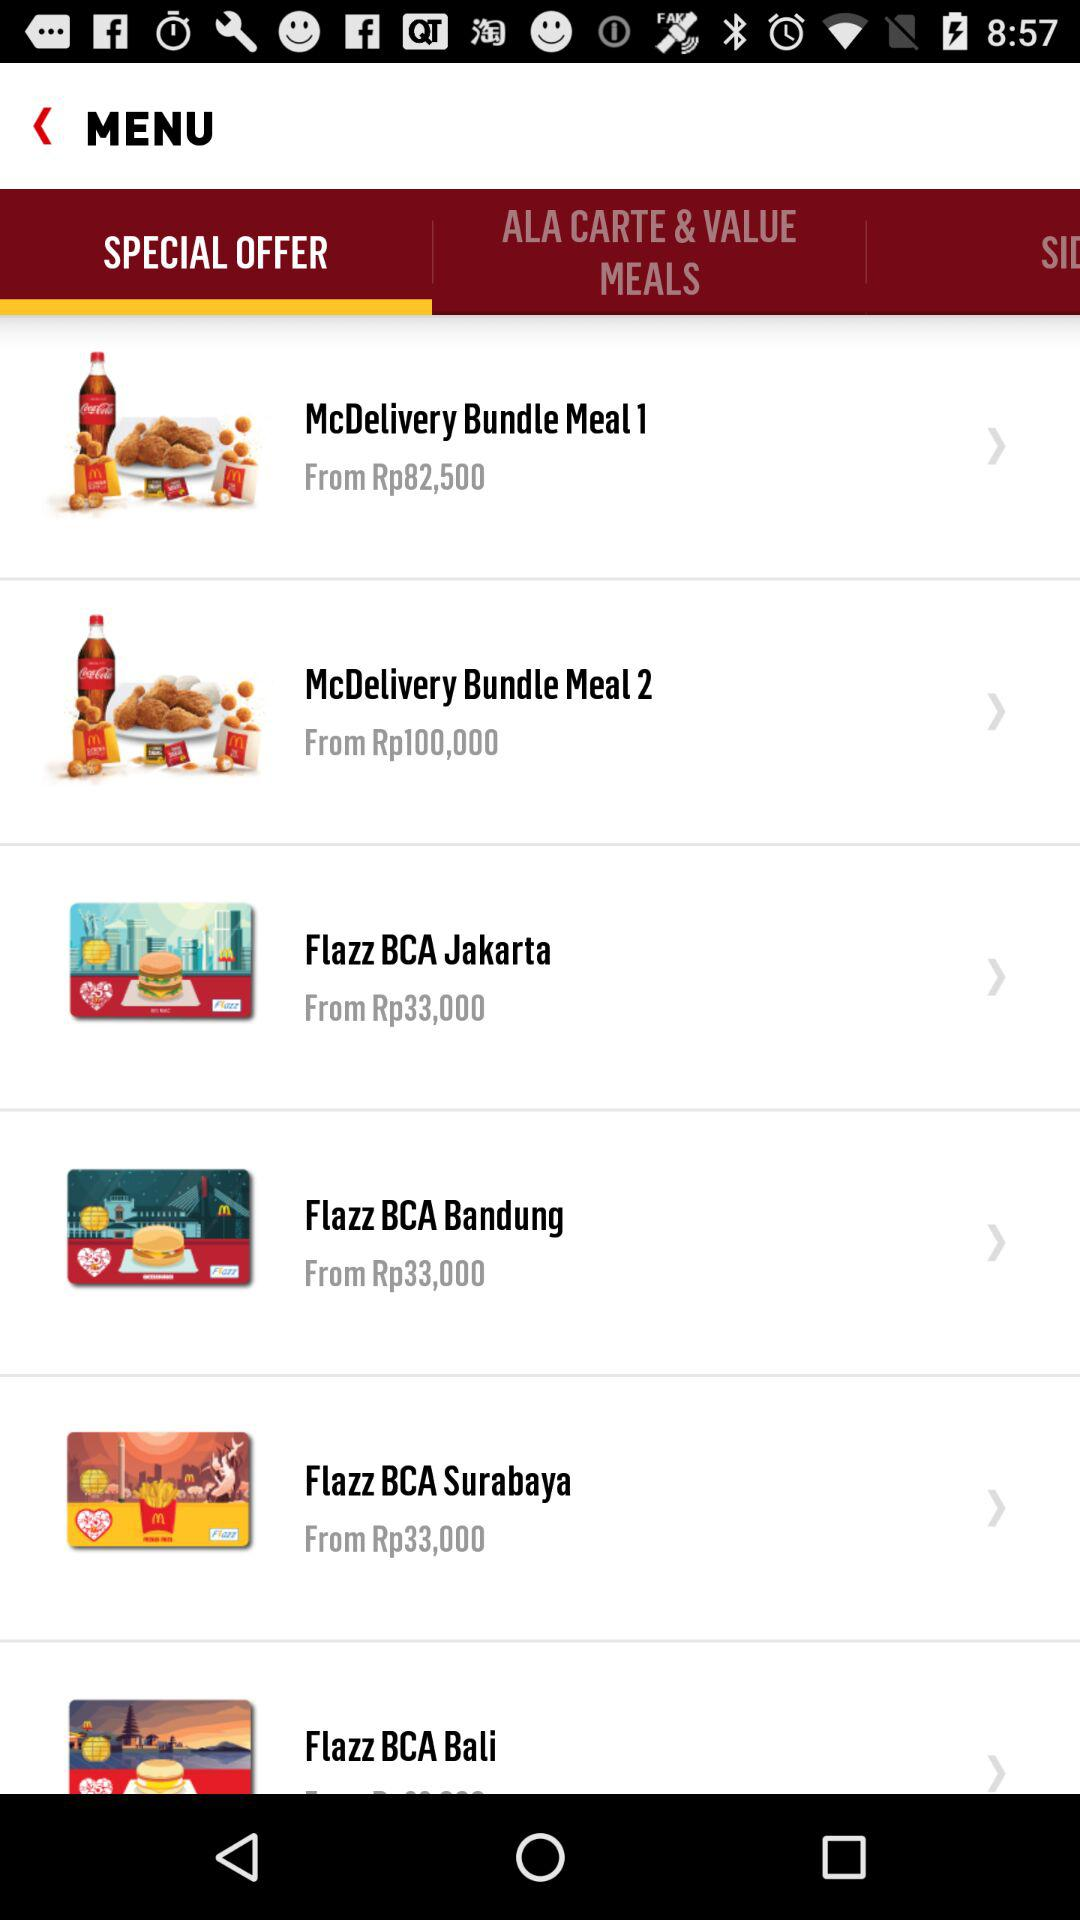What is the price of "McDelivery Bundle Meal 1"? The price of "McDelivery Bundle Meal 1" starts at Rp82,500. 